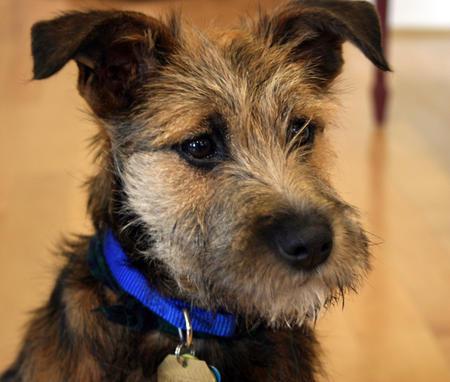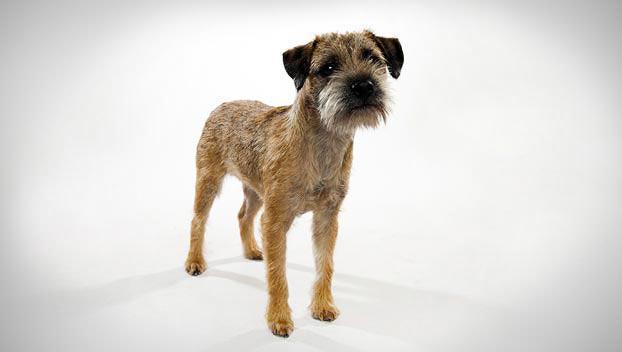The first image is the image on the left, the second image is the image on the right. Considering the images on both sides, is "One dog has a collar or leash." valid? Answer yes or no. Yes. The first image is the image on the left, the second image is the image on the right. Given the left and right images, does the statement "One photo shows the full body of an adult dog against a plain white background." hold true? Answer yes or no. Yes. 